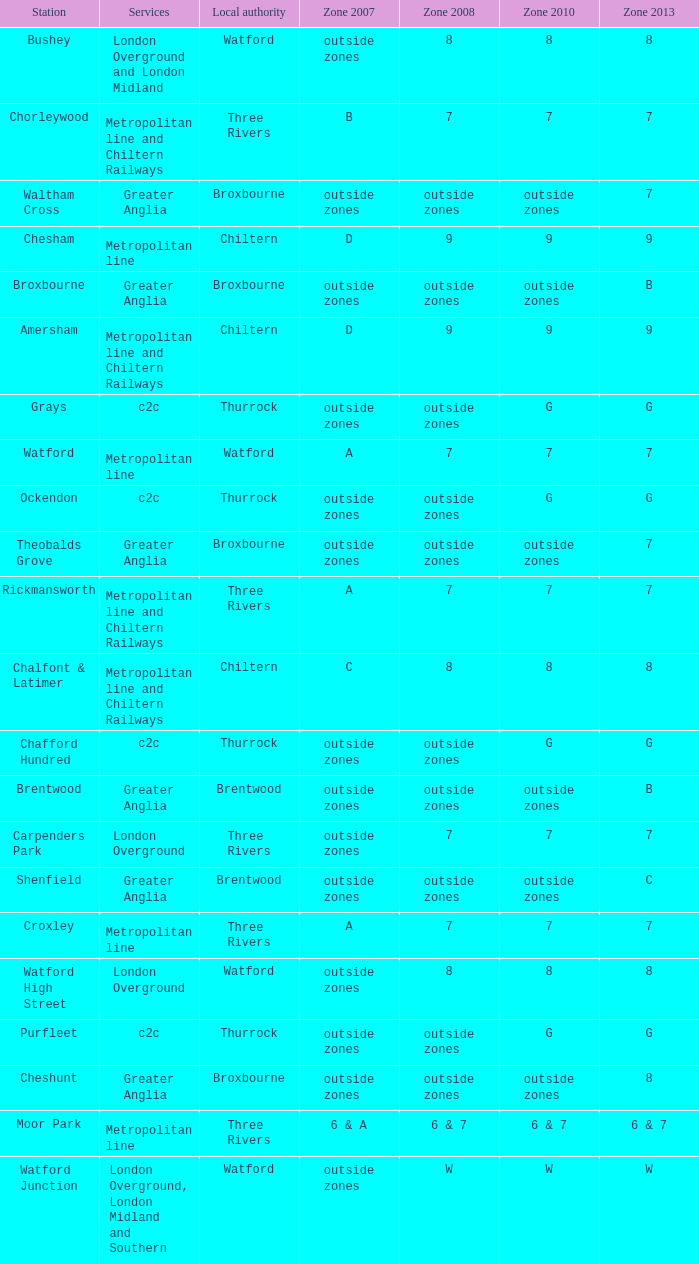Would you be able to parse every entry in this table? {'header': ['Station', 'Services', 'Local authority', 'Zone 2007', 'Zone 2008', 'Zone 2010', 'Zone 2013'], 'rows': [['Bushey', 'London Overground and London Midland', 'Watford', 'outside zones', '8', '8', '8'], ['Chorleywood', 'Metropolitan line and Chiltern Railways', 'Three Rivers', 'B', '7', '7', '7'], ['Waltham Cross', 'Greater Anglia', 'Broxbourne', 'outside zones', 'outside zones', 'outside zones', '7'], ['Chesham', 'Metropolitan line', 'Chiltern', 'D', '9', '9', '9'], ['Broxbourne', 'Greater Anglia', 'Broxbourne', 'outside zones', 'outside zones', 'outside zones', 'B'], ['Amersham', 'Metropolitan line and Chiltern Railways', 'Chiltern', 'D', '9', '9', '9'], ['Grays', 'c2c', 'Thurrock', 'outside zones', 'outside zones', 'G', 'G'], ['Watford', 'Metropolitan line', 'Watford', 'A', '7', '7', '7'], ['Ockendon', 'c2c', 'Thurrock', 'outside zones', 'outside zones', 'G', 'G'], ['Theobalds Grove', 'Greater Anglia', 'Broxbourne', 'outside zones', 'outside zones', 'outside zones', '7'], ['Rickmansworth', 'Metropolitan line and Chiltern Railways', 'Three Rivers', 'A', '7', '7', '7'], ['Chalfont & Latimer', 'Metropolitan line and Chiltern Railways', 'Chiltern', 'C', '8', '8', '8'], ['Chafford Hundred', 'c2c', 'Thurrock', 'outside zones', 'outside zones', 'G', 'G'], ['Brentwood', 'Greater Anglia', 'Brentwood', 'outside zones', 'outside zones', 'outside zones', 'B'], ['Carpenders Park', 'London Overground', 'Three Rivers', 'outside zones', '7', '7', '7'], ['Shenfield', 'Greater Anglia', 'Brentwood', 'outside zones', 'outside zones', 'outside zones', 'C'], ['Croxley', 'Metropolitan line', 'Three Rivers', 'A', '7', '7', '7'], ['Watford High Street', 'London Overground', 'Watford', 'outside zones', '8', '8', '8'], ['Purfleet', 'c2c', 'Thurrock', 'outside zones', 'outside zones', 'G', 'G'], ['Cheshunt', 'Greater Anglia', 'Broxbourne', 'outside zones', 'outside zones', 'outside zones', '8'], ['Moor Park', 'Metropolitan line', 'Three Rivers', '6 & A', '6 & 7', '6 & 7', '6 & 7'], ['Watford Junction', 'London Overground, London Midland and Southern', 'Watford', 'outside zones', 'W', 'W', 'W']]} Which Zone 2008 has Services of greater anglia, and a Station of cheshunt? Outside zones. 